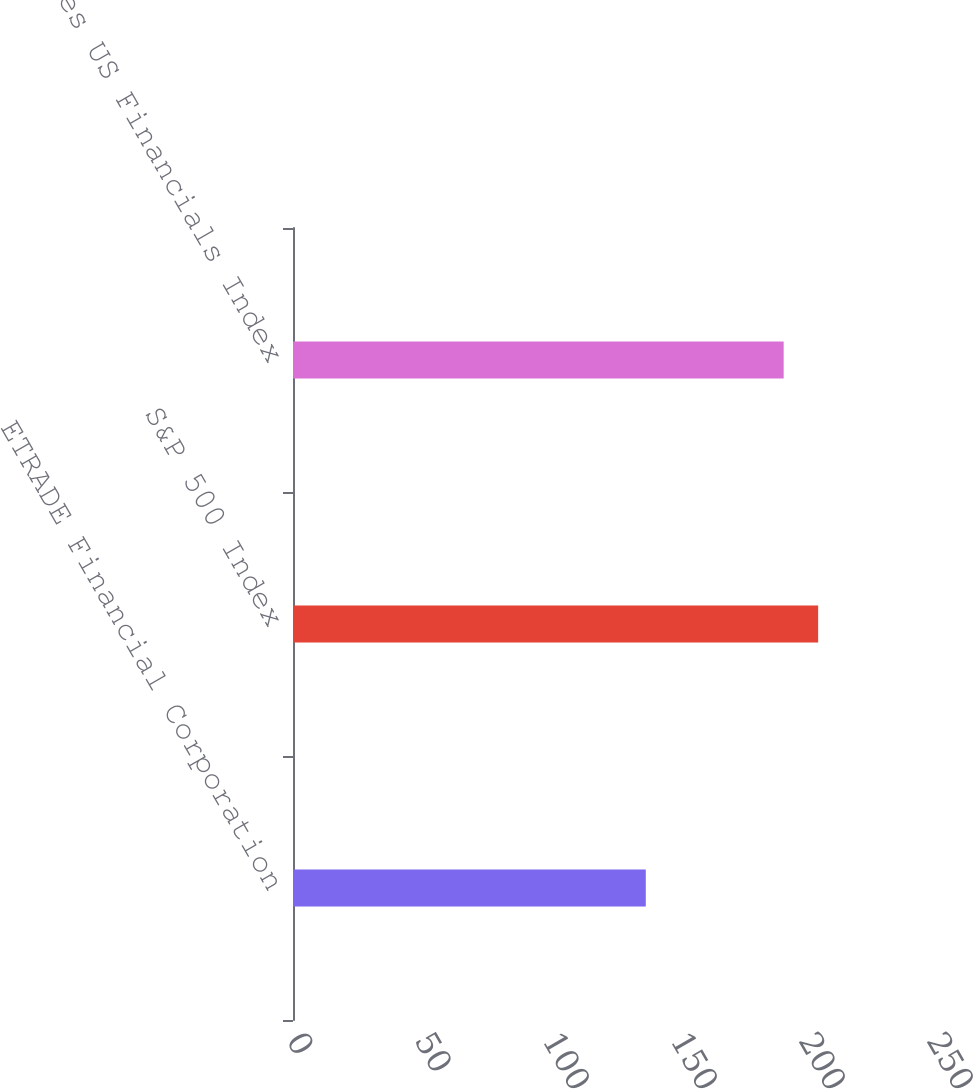Convert chart to OTSL. <chart><loc_0><loc_0><loc_500><loc_500><bar_chart><fcel>ETRADE Financial Corporation<fcel>S&P 500 Index<fcel>Dow Jones US Financials Index<nl><fcel>137.81<fcel>205.14<fcel>191.67<nl></chart> 